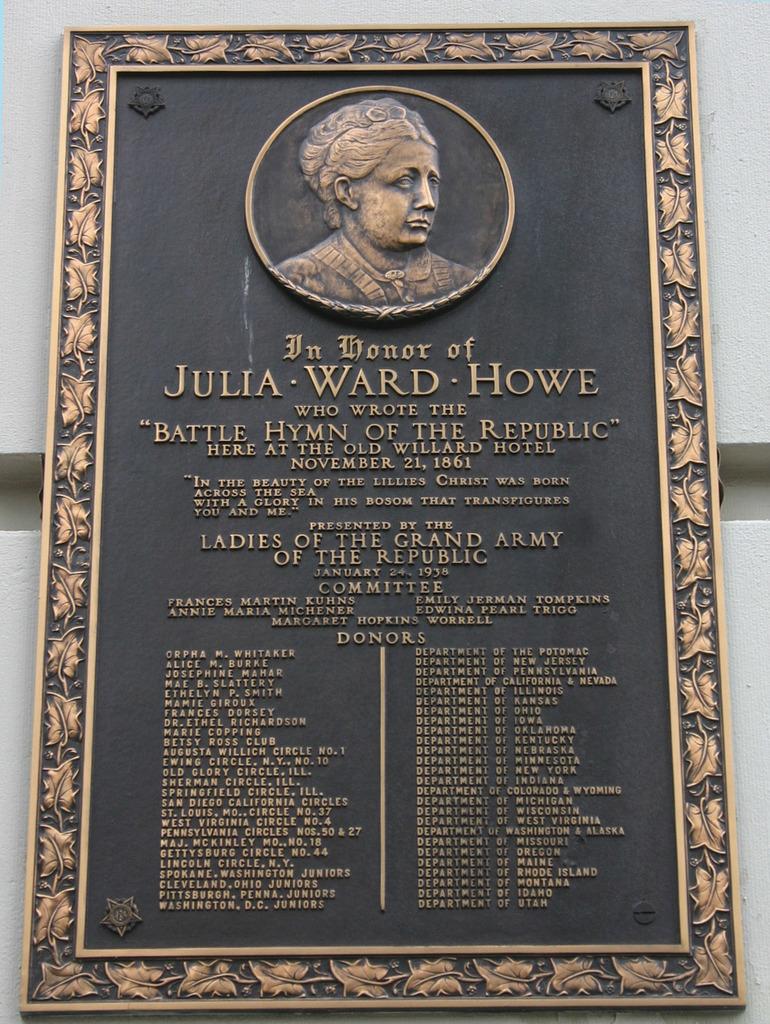Who is the plaque in honor of?
Offer a terse response. Julia ward howe. Julia ward howe?
Your answer should be very brief. Yes. 